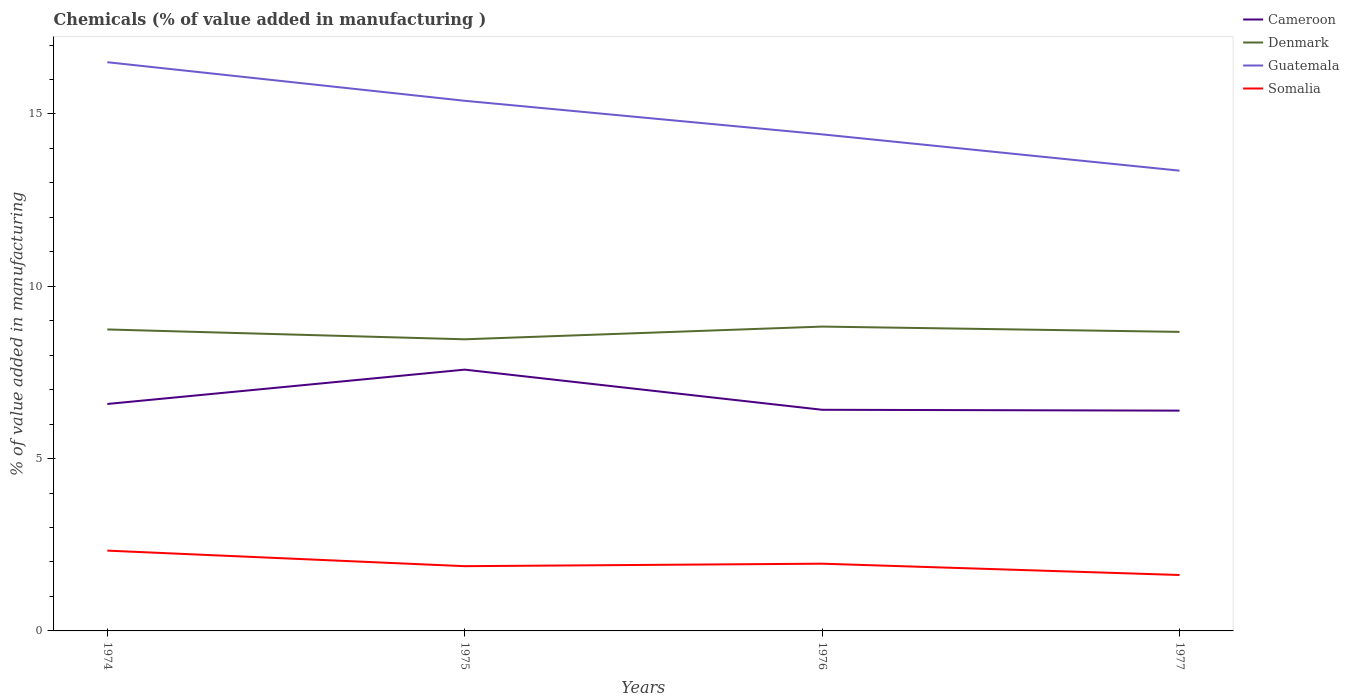Is the number of lines equal to the number of legend labels?
Give a very brief answer. Yes. Across all years, what is the maximum value added in manufacturing chemicals in Guatemala?
Provide a short and direct response. 13.36. In which year was the value added in manufacturing chemicals in Denmark maximum?
Your response must be concise. 1975. What is the total value added in manufacturing chemicals in Somalia in the graph?
Make the answer very short. 0.26. What is the difference between the highest and the second highest value added in manufacturing chemicals in Denmark?
Make the answer very short. 0.37. What is the difference between the highest and the lowest value added in manufacturing chemicals in Denmark?
Offer a very short reply. 2. How many lines are there?
Keep it short and to the point. 4. How many years are there in the graph?
Ensure brevity in your answer.  4. Where does the legend appear in the graph?
Offer a very short reply. Top right. What is the title of the graph?
Make the answer very short. Chemicals (% of value added in manufacturing ). What is the label or title of the Y-axis?
Ensure brevity in your answer.  % of value added in manufacturing. What is the % of value added in manufacturing in Cameroon in 1974?
Your answer should be compact. 6.59. What is the % of value added in manufacturing of Denmark in 1974?
Your response must be concise. 8.75. What is the % of value added in manufacturing in Guatemala in 1974?
Offer a very short reply. 16.5. What is the % of value added in manufacturing of Somalia in 1974?
Provide a succinct answer. 2.33. What is the % of value added in manufacturing of Cameroon in 1975?
Provide a succinct answer. 7.58. What is the % of value added in manufacturing in Denmark in 1975?
Give a very brief answer. 8.46. What is the % of value added in manufacturing in Guatemala in 1975?
Offer a terse response. 15.38. What is the % of value added in manufacturing in Somalia in 1975?
Offer a very short reply. 1.88. What is the % of value added in manufacturing of Cameroon in 1976?
Provide a succinct answer. 6.42. What is the % of value added in manufacturing of Denmark in 1976?
Make the answer very short. 8.83. What is the % of value added in manufacturing in Guatemala in 1976?
Keep it short and to the point. 14.41. What is the % of value added in manufacturing in Somalia in 1976?
Your answer should be very brief. 1.95. What is the % of value added in manufacturing of Cameroon in 1977?
Make the answer very short. 6.39. What is the % of value added in manufacturing in Denmark in 1977?
Your response must be concise. 8.68. What is the % of value added in manufacturing in Guatemala in 1977?
Give a very brief answer. 13.36. What is the % of value added in manufacturing in Somalia in 1977?
Offer a very short reply. 1.62. Across all years, what is the maximum % of value added in manufacturing in Cameroon?
Make the answer very short. 7.58. Across all years, what is the maximum % of value added in manufacturing in Denmark?
Your answer should be very brief. 8.83. Across all years, what is the maximum % of value added in manufacturing in Guatemala?
Your answer should be compact. 16.5. Across all years, what is the maximum % of value added in manufacturing in Somalia?
Your response must be concise. 2.33. Across all years, what is the minimum % of value added in manufacturing in Cameroon?
Provide a succinct answer. 6.39. Across all years, what is the minimum % of value added in manufacturing of Denmark?
Offer a terse response. 8.46. Across all years, what is the minimum % of value added in manufacturing in Guatemala?
Give a very brief answer. 13.36. Across all years, what is the minimum % of value added in manufacturing in Somalia?
Ensure brevity in your answer.  1.62. What is the total % of value added in manufacturing of Cameroon in the graph?
Provide a short and direct response. 26.98. What is the total % of value added in manufacturing of Denmark in the graph?
Provide a short and direct response. 34.72. What is the total % of value added in manufacturing of Guatemala in the graph?
Keep it short and to the point. 59.65. What is the total % of value added in manufacturing of Somalia in the graph?
Keep it short and to the point. 7.78. What is the difference between the % of value added in manufacturing in Cameroon in 1974 and that in 1975?
Offer a very short reply. -1. What is the difference between the % of value added in manufacturing in Denmark in 1974 and that in 1975?
Offer a terse response. 0.29. What is the difference between the % of value added in manufacturing of Guatemala in 1974 and that in 1975?
Your answer should be very brief. 1.12. What is the difference between the % of value added in manufacturing of Somalia in 1974 and that in 1975?
Give a very brief answer. 0.45. What is the difference between the % of value added in manufacturing of Cameroon in 1974 and that in 1976?
Offer a very short reply. 0.17. What is the difference between the % of value added in manufacturing of Denmark in 1974 and that in 1976?
Offer a very short reply. -0.08. What is the difference between the % of value added in manufacturing in Guatemala in 1974 and that in 1976?
Make the answer very short. 2.09. What is the difference between the % of value added in manufacturing of Somalia in 1974 and that in 1976?
Ensure brevity in your answer.  0.38. What is the difference between the % of value added in manufacturing in Cameroon in 1974 and that in 1977?
Your response must be concise. 0.19. What is the difference between the % of value added in manufacturing of Denmark in 1974 and that in 1977?
Your answer should be compact. 0.07. What is the difference between the % of value added in manufacturing of Guatemala in 1974 and that in 1977?
Give a very brief answer. 3.15. What is the difference between the % of value added in manufacturing in Somalia in 1974 and that in 1977?
Keep it short and to the point. 0.71. What is the difference between the % of value added in manufacturing of Cameroon in 1975 and that in 1976?
Offer a terse response. 1.16. What is the difference between the % of value added in manufacturing of Denmark in 1975 and that in 1976?
Your answer should be compact. -0.37. What is the difference between the % of value added in manufacturing in Somalia in 1975 and that in 1976?
Provide a short and direct response. -0.07. What is the difference between the % of value added in manufacturing in Cameroon in 1975 and that in 1977?
Provide a short and direct response. 1.19. What is the difference between the % of value added in manufacturing in Denmark in 1975 and that in 1977?
Keep it short and to the point. -0.22. What is the difference between the % of value added in manufacturing of Guatemala in 1975 and that in 1977?
Provide a succinct answer. 2.03. What is the difference between the % of value added in manufacturing in Somalia in 1975 and that in 1977?
Keep it short and to the point. 0.26. What is the difference between the % of value added in manufacturing of Cameroon in 1976 and that in 1977?
Offer a terse response. 0.02. What is the difference between the % of value added in manufacturing of Denmark in 1976 and that in 1977?
Your response must be concise. 0.15. What is the difference between the % of value added in manufacturing in Guatemala in 1976 and that in 1977?
Your answer should be very brief. 1.05. What is the difference between the % of value added in manufacturing in Somalia in 1976 and that in 1977?
Your answer should be compact. 0.33. What is the difference between the % of value added in manufacturing of Cameroon in 1974 and the % of value added in manufacturing of Denmark in 1975?
Offer a very short reply. -1.88. What is the difference between the % of value added in manufacturing in Cameroon in 1974 and the % of value added in manufacturing in Guatemala in 1975?
Your answer should be very brief. -8.8. What is the difference between the % of value added in manufacturing of Cameroon in 1974 and the % of value added in manufacturing of Somalia in 1975?
Provide a succinct answer. 4.71. What is the difference between the % of value added in manufacturing in Denmark in 1974 and the % of value added in manufacturing in Guatemala in 1975?
Offer a terse response. -6.63. What is the difference between the % of value added in manufacturing of Denmark in 1974 and the % of value added in manufacturing of Somalia in 1975?
Your answer should be very brief. 6.87. What is the difference between the % of value added in manufacturing of Guatemala in 1974 and the % of value added in manufacturing of Somalia in 1975?
Make the answer very short. 14.62. What is the difference between the % of value added in manufacturing of Cameroon in 1974 and the % of value added in manufacturing of Denmark in 1976?
Offer a terse response. -2.25. What is the difference between the % of value added in manufacturing in Cameroon in 1974 and the % of value added in manufacturing in Guatemala in 1976?
Your answer should be very brief. -7.82. What is the difference between the % of value added in manufacturing of Cameroon in 1974 and the % of value added in manufacturing of Somalia in 1976?
Keep it short and to the point. 4.63. What is the difference between the % of value added in manufacturing in Denmark in 1974 and the % of value added in manufacturing in Guatemala in 1976?
Your answer should be very brief. -5.66. What is the difference between the % of value added in manufacturing in Denmark in 1974 and the % of value added in manufacturing in Somalia in 1976?
Make the answer very short. 6.8. What is the difference between the % of value added in manufacturing of Guatemala in 1974 and the % of value added in manufacturing of Somalia in 1976?
Give a very brief answer. 14.55. What is the difference between the % of value added in manufacturing of Cameroon in 1974 and the % of value added in manufacturing of Denmark in 1977?
Ensure brevity in your answer.  -2.09. What is the difference between the % of value added in manufacturing of Cameroon in 1974 and the % of value added in manufacturing of Guatemala in 1977?
Offer a terse response. -6.77. What is the difference between the % of value added in manufacturing of Cameroon in 1974 and the % of value added in manufacturing of Somalia in 1977?
Your answer should be compact. 4.96. What is the difference between the % of value added in manufacturing of Denmark in 1974 and the % of value added in manufacturing of Guatemala in 1977?
Keep it short and to the point. -4.61. What is the difference between the % of value added in manufacturing of Denmark in 1974 and the % of value added in manufacturing of Somalia in 1977?
Your answer should be very brief. 7.12. What is the difference between the % of value added in manufacturing in Guatemala in 1974 and the % of value added in manufacturing in Somalia in 1977?
Give a very brief answer. 14.88. What is the difference between the % of value added in manufacturing in Cameroon in 1975 and the % of value added in manufacturing in Denmark in 1976?
Your answer should be very brief. -1.25. What is the difference between the % of value added in manufacturing in Cameroon in 1975 and the % of value added in manufacturing in Guatemala in 1976?
Offer a very short reply. -6.83. What is the difference between the % of value added in manufacturing in Cameroon in 1975 and the % of value added in manufacturing in Somalia in 1976?
Offer a very short reply. 5.63. What is the difference between the % of value added in manufacturing of Denmark in 1975 and the % of value added in manufacturing of Guatemala in 1976?
Ensure brevity in your answer.  -5.95. What is the difference between the % of value added in manufacturing of Denmark in 1975 and the % of value added in manufacturing of Somalia in 1976?
Keep it short and to the point. 6.51. What is the difference between the % of value added in manufacturing of Guatemala in 1975 and the % of value added in manufacturing of Somalia in 1976?
Keep it short and to the point. 13.43. What is the difference between the % of value added in manufacturing of Cameroon in 1975 and the % of value added in manufacturing of Denmark in 1977?
Offer a very short reply. -1.1. What is the difference between the % of value added in manufacturing of Cameroon in 1975 and the % of value added in manufacturing of Guatemala in 1977?
Provide a short and direct response. -5.77. What is the difference between the % of value added in manufacturing of Cameroon in 1975 and the % of value added in manufacturing of Somalia in 1977?
Offer a very short reply. 5.96. What is the difference between the % of value added in manufacturing of Denmark in 1975 and the % of value added in manufacturing of Guatemala in 1977?
Provide a succinct answer. -4.89. What is the difference between the % of value added in manufacturing of Denmark in 1975 and the % of value added in manufacturing of Somalia in 1977?
Provide a short and direct response. 6.84. What is the difference between the % of value added in manufacturing in Guatemala in 1975 and the % of value added in manufacturing in Somalia in 1977?
Offer a terse response. 13.76. What is the difference between the % of value added in manufacturing in Cameroon in 1976 and the % of value added in manufacturing in Denmark in 1977?
Your answer should be very brief. -2.26. What is the difference between the % of value added in manufacturing in Cameroon in 1976 and the % of value added in manufacturing in Guatemala in 1977?
Ensure brevity in your answer.  -6.94. What is the difference between the % of value added in manufacturing of Cameroon in 1976 and the % of value added in manufacturing of Somalia in 1977?
Provide a short and direct response. 4.79. What is the difference between the % of value added in manufacturing in Denmark in 1976 and the % of value added in manufacturing in Guatemala in 1977?
Give a very brief answer. -4.52. What is the difference between the % of value added in manufacturing of Denmark in 1976 and the % of value added in manufacturing of Somalia in 1977?
Your answer should be very brief. 7.21. What is the difference between the % of value added in manufacturing of Guatemala in 1976 and the % of value added in manufacturing of Somalia in 1977?
Your answer should be compact. 12.79. What is the average % of value added in manufacturing in Cameroon per year?
Give a very brief answer. 6.74. What is the average % of value added in manufacturing in Denmark per year?
Keep it short and to the point. 8.68. What is the average % of value added in manufacturing in Guatemala per year?
Make the answer very short. 14.91. What is the average % of value added in manufacturing of Somalia per year?
Your answer should be compact. 1.95. In the year 1974, what is the difference between the % of value added in manufacturing in Cameroon and % of value added in manufacturing in Denmark?
Keep it short and to the point. -2.16. In the year 1974, what is the difference between the % of value added in manufacturing of Cameroon and % of value added in manufacturing of Guatemala?
Keep it short and to the point. -9.92. In the year 1974, what is the difference between the % of value added in manufacturing of Cameroon and % of value added in manufacturing of Somalia?
Provide a short and direct response. 4.26. In the year 1974, what is the difference between the % of value added in manufacturing in Denmark and % of value added in manufacturing in Guatemala?
Provide a succinct answer. -7.75. In the year 1974, what is the difference between the % of value added in manufacturing in Denmark and % of value added in manufacturing in Somalia?
Your answer should be compact. 6.42. In the year 1974, what is the difference between the % of value added in manufacturing of Guatemala and % of value added in manufacturing of Somalia?
Ensure brevity in your answer.  14.17. In the year 1975, what is the difference between the % of value added in manufacturing in Cameroon and % of value added in manufacturing in Denmark?
Offer a terse response. -0.88. In the year 1975, what is the difference between the % of value added in manufacturing of Cameroon and % of value added in manufacturing of Guatemala?
Provide a succinct answer. -7.8. In the year 1975, what is the difference between the % of value added in manufacturing of Cameroon and % of value added in manufacturing of Somalia?
Your answer should be compact. 5.7. In the year 1975, what is the difference between the % of value added in manufacturing of Denmark and % of value added in manufacturing of Guatemala?
Offer a terse response. -6.92. In the year 1975, what is the difference between the % of value added in manufacturing in Denmark and % of value added in manufacturing in Somalia?
Give a very brief answer. 6.58. In the year 1975, what is the difference between the % of value added in manufacturing of Guatemala and % of value added in manufacturing of Somalia?
Give a very brief answer. 13.5. In the year 1976, what is the difference between the % of value added in manufacturing of Cameroon and % of value added in manufacturing of Denmark?
Your response must be concise. -2.41. In the year 1976, what is the difference between the % of value added in manufacturing in Cameroon and % of value added in manufacturing in Guatemala?
Provide a succinct answer. -7.99. In the year 1976, what is the difference between the % of value added in manufacturing in Cameroon and % of value added in manufacturing in Somalia?
Offer a terse response. 4.47. In the year 1976, what is the difference between the % of value added in manufacturing of Denmark and % of value added in manufacturing of Guatemala?
Provide a succinct answer. -5.58. In the year 1976, what is the difference between the % of value added in manufacturing of Denmark and % of value added in manufacturing of Somalia?
Keep it short and to the point. 6.88. In the year 1976, what is the difference between the % of value added in manufacturing in Guatemala and % of value added in manufacturing in Somalia?
Provide a succinct answer. 12.46. In the year 1977, what is the difference between the % of value added in manufacturing of Cameroon and % of value added in manufacturing of Denmark?
Provide a short and direct response. -2.29. In the year 1977, what is the difference between the % of value added in manufacturing in Cameroon and % of value added in manufacturing in Guatemala?
Provide a succinct answer. -6.96. In the year 1977, what is the difference between the % of value added in manufacturing in Cameroon and % of value added in manufacturing in Somalia?
Offer a terse response. 4.77. In the year 1977, what is the difference between the % of value added in manufacturing in Denmark and % of value added in manufacturing in Guatemala?
Provide a short and direct response. -4.68. In the year 1977, what is the difference between the % of value added in manufacturing in Denmark and % of value added in manufacturing in Somalia?
Your response must be concise. 7.05. In the year 1977, what is the difference between the % of value added in manufacturing in Guatemala and % of value added in manufacturing in Somalia?
Ensure brevity in your answer.  11.73. What is the ratio of the % of value added in manufacturing in Cameroon in 1974 to that in 1975?
Your answer should be compact. 0.87. What is the ratio of the % of value added in manufacturing of Denmark in 1974 to that in 1975?
Your answer should be compact. 1.03. What is the ratio of the % of value added in manufacturing of Guatemala in 1974 to that in 1975?
Your response must be concise. 1.07. What is the ratio of the % of value added in manufacturing of Somalia in 1974 to that in 1975?
Make the answer very short. 1.24. What is the ratio of the % of value added in manufacturing of Cameroon in 1974 to that in 1976?
Your response must be concise. 1.03. What is the ratio of the % of value added in manufacturing of Denmark in 1974 to that in 1976?
Provide a short and direct response. 0.99. What is the ratio of the % of value added in manufacturing of Guatemala in 1974 to that in 1976?
Your response must be concise. 1.15. What is the ratio of the % of value added in manufacturing of Somalia in 1974 to that in 1976?
Your answer should be compact. 1.19. What is the ratio of the % of value added in manufacturing in Cameroon in 1974 to that in 1977?
Keep it short and to the point. 1.03. What is the ratio of the % of value added in manufacturing in Denmark in 1974 to that in 1977?
Offer a terse response. 1.01. What is the ratio of the % of value added in manufacturing in Guatemala in 1974 to that in 1977?
Your answer should be very brief. 1.24. What is the ratio of the % of value added in manufacturing of Somalia in 1974 to that in 1977?
Offer a terse response. 1.44. What is the ratio of the % of value added in manufacturing in Cameroon in 1975 to that in 1976?
Make the answer very short. 1.18. What is the ratio of the % of value added in manufacturing of Denmark in 1975 to that in 1976?
Provide a succinct answer. 0.96. What is the ratio of the % of value added in manufacturing in Guatemala in 1975 to that in 1976?
Provide a succinct answer. 1.07. What is the ratio of the % of value added in manufacturing in Somalia in 1975 to that in 1976?
Your response must be concise. 0.96. What is the ratio of the % of value added in manufacturing in Cameroon in 1975 to that in 1977?
Keep it short and to the point. 1.19. What is the ratio of the % of value added in manufacturing of Denmark in 1975 to that in 1977?
Ensure brevity in your answer.  0.98. What is the ratio of the % of value added in manufacturing of Guatemala in 1975 to that in 1977?
Make the answer very short. 1.15. What is the ratio of the % of value added in manufacturing of Somalia in 1975 to that in 1977?
Ensure brevity in your answer.  1.16. What is the ratio of the % of value added in manufacturing in Denmark in 1976 to that in 1977?
Keep it short and to the point. 1.02. What is the ratio of the % of value added in manufacturing of Guatemala in 1976 to that in 1977?
Provide a short and direct response. 1.08. What is the ratio of the % of value added in manufacturing in Somalia in 1976 to that in 1977?
Make the answer very short. 1.2. What is the difference between the highest and the second highest % of value added in manufacturing of Cameroon?
Make the answer very short. 1. What is the difference between the highest and the second highest % of value added in manufacturing in Denmark?
Give a very brief answer. 0.08. What is the difference between the highest and the second highest % of value added in manufacturing of Guatemala?
Offer a terse response. 1.12. What is the difference between the highest and the second highest % of value added in manufacturing in Somalia?
Offer a very short reply. 0.38. What is the difference between the highest and the lowest % of value added in manufacturing in Cameroon?
Offer a terse response. 1.19. What is the difference between the highest and the lowest % of value added in manufacturing in Denmark?
Your response must be concise. 0.37. What is the difference between the highest and the lowest % of value added in manufacturing of Guatemala?
Ensure brevity in your answer.  3.15. What is the difference between the highest and the lowest % of value added in manufacturing of Somalia?
Provide a succinct answer. 0.71. 